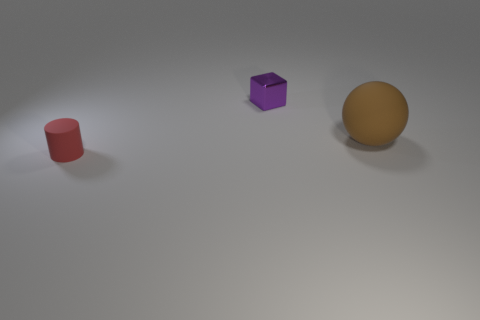Are there the same number of large matte things behind the purple object and tiny red rubber cylinders?
Offer a terse response. No. What number of other things are the same size as the red rubber cylinder?
Give a very brief answer. 1. Do the tiny thing that is behind the tiny cylinder and the object that is in front of the brown matte sphere have the same material?
Keep it short and to the point. No. What is the size of the rubber thing that is to the left of the rubber thing behind the tiny red thing?
Keep it short and to the point. Small. Is there another matte cylinder of the same color as the matte cylinder?
Keep it short and to the point. No. Does the matte object that is in front of the sphere have the same color as the rubber thing that is behind the tiny red thing?
Make the answer very short. No. What is the shape of the large brown matte object?
Your response must be concise. Sphere. There is a tiny cube; what number of blocks are on the left side of it?
Your answer should be very brief. 0. How many red objects have the same material as the big brown thing?
Ensure brevity in your answer.  1. Does the small object behind the rubber sphere have the same material as the small red object?
Ensure brevity in your answer.  No. 